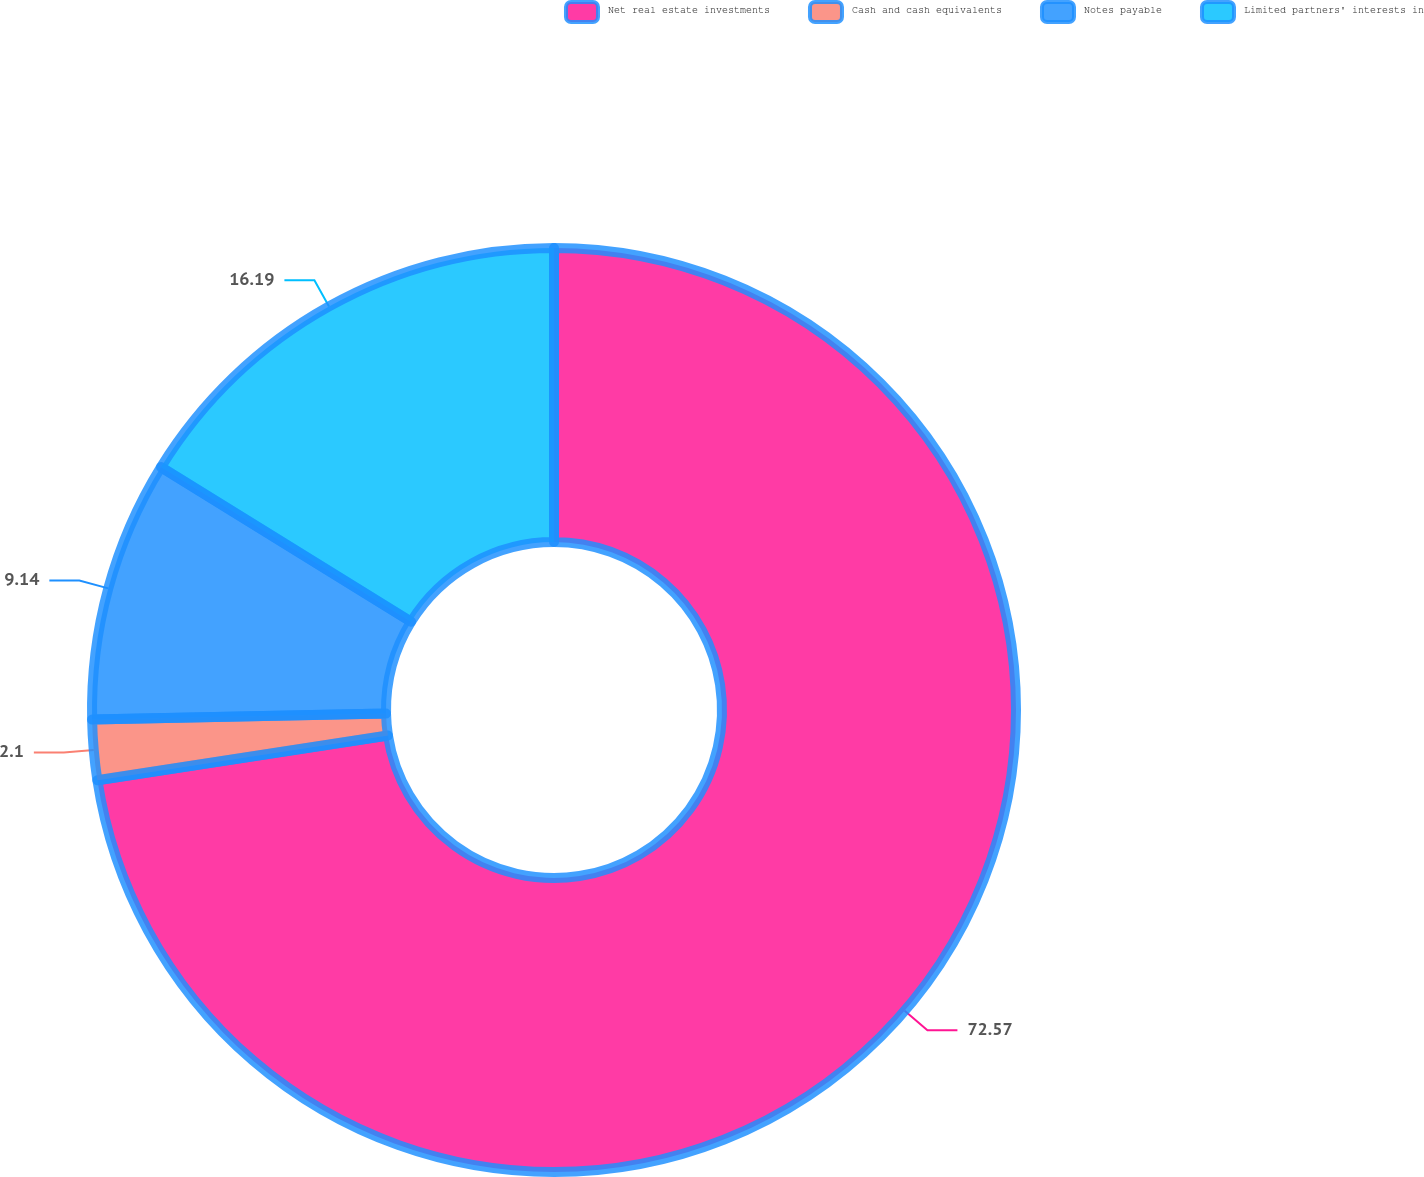Convert chart. <chart><loc_0><loc_0><loc_500><loc_500><pie_chart><fcel>Net real estate investments<fcel>Cash and cash equivalents<fcel>Notes payable<fcel>Limited partners' interests in<nl><fcel>72.57%<fcel>2.1%<fcel>9.14%<fcel>16.19%<nl></chart> 